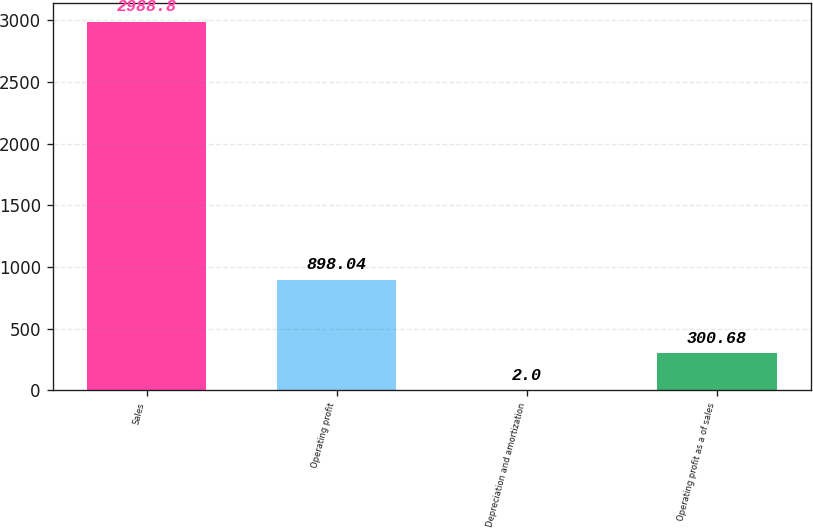Convert chart to OTSL. <chart><loc_0><loc_0><loc_500><loc_500><bar_chart><fcel>Sales<fcel>Operating profit<fcel>Depreciation and amortization<fcel>Operating profit as a of sales<nl><fcel>2988.8<fcel>898.04<fcel>2<fcel>300.68<nl></chart> 